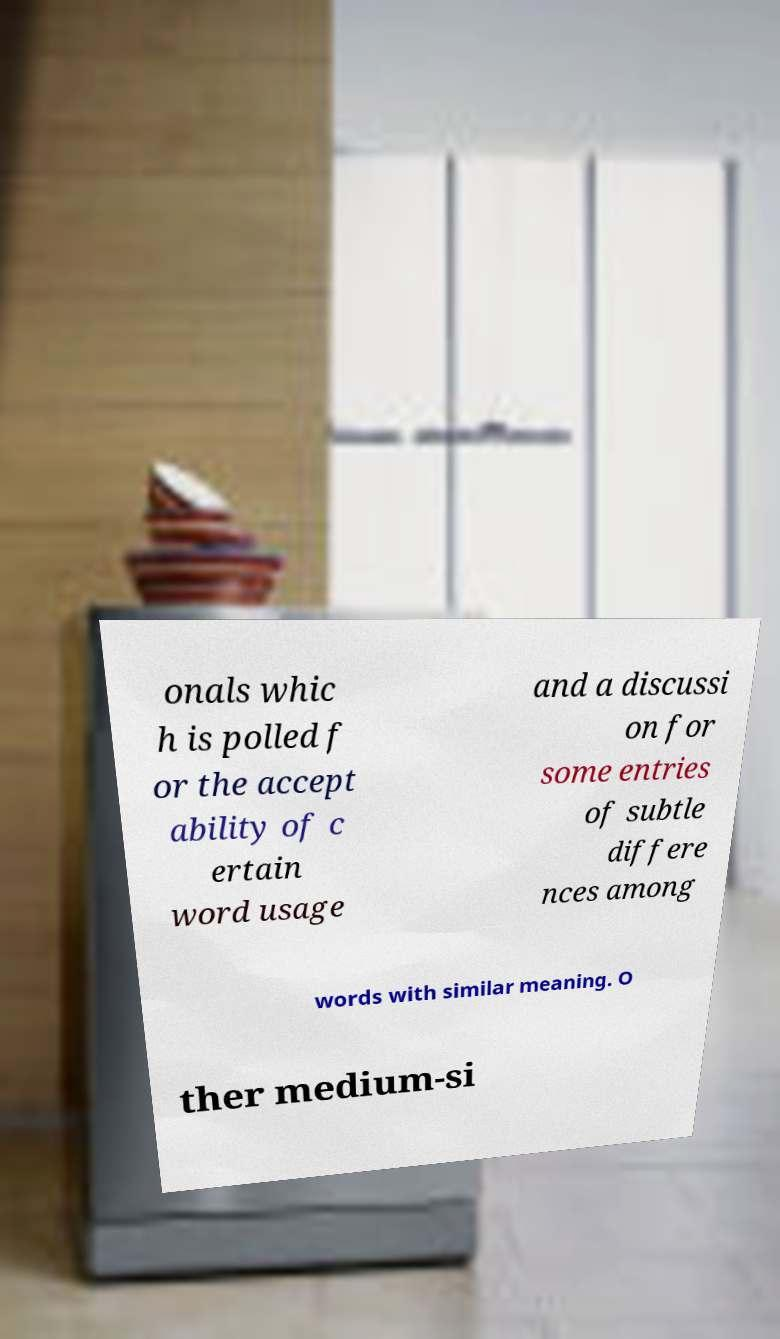Can you read and provide the text displayed in the image?This photo seems to have some interesting text. Can you extract and type it out for me? onals whic h is polled f or the accept ability of c ertain word usage and a discussi on for some entries of subtle differe nces among words with similar meaning. O ther medium-si 